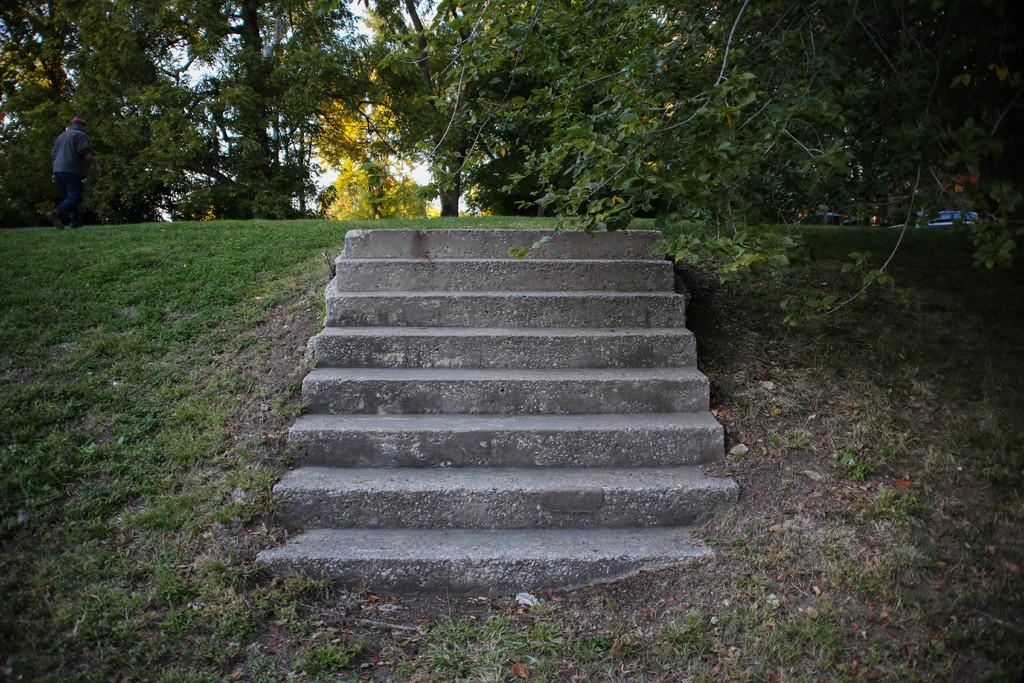What type of structure is present in the image? There is a staircase in the image. How is the staircase situated in relation to the landscape? The staircase is constructed on a small hill. Can you describe the background of the image? There is a person and trees in the background of the image, and the sky is also visible. What type of poison is being used by the person in the image? There is no person using poison in the image; it only shows a staircase on a small hill with trees and the sky in the background. 